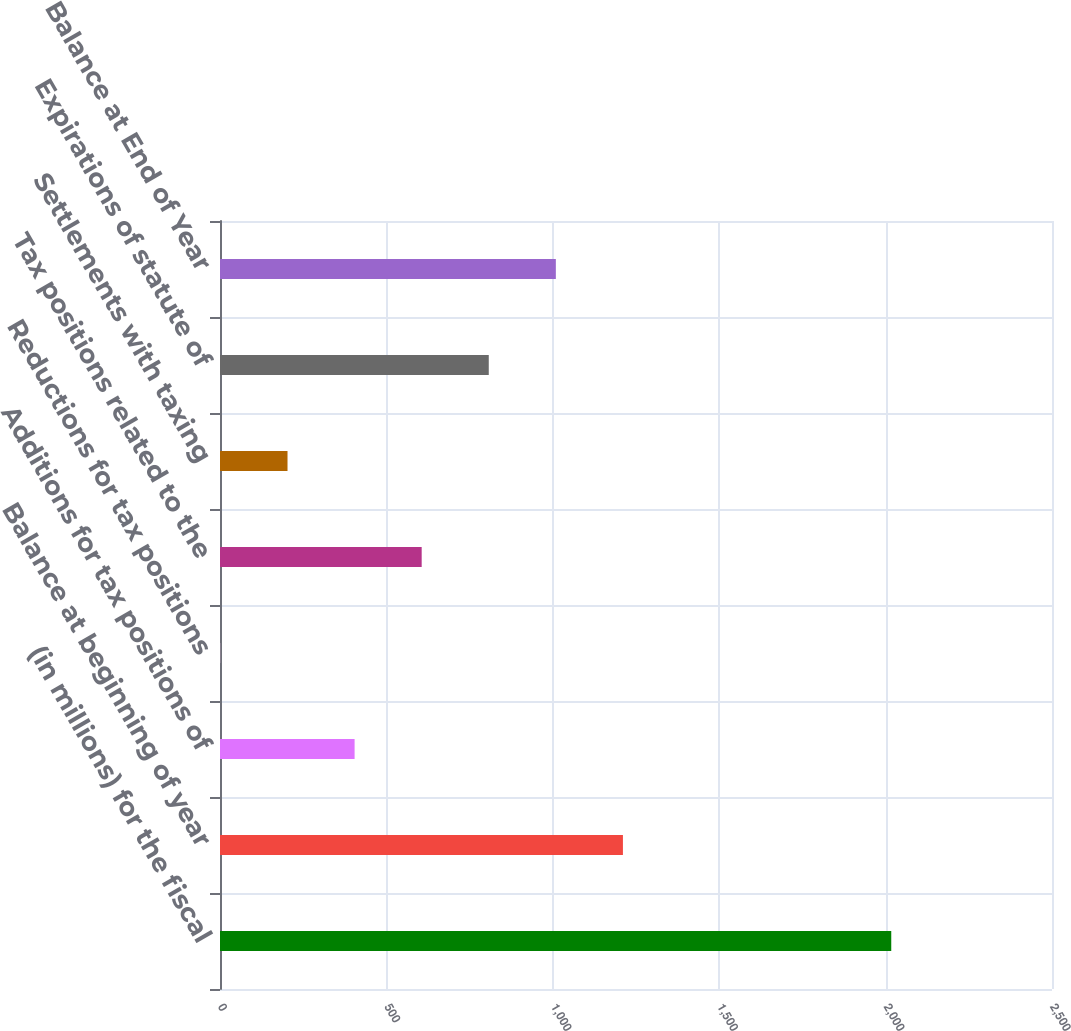<chart> <loc_0><loc_0><loc_500><loc_500><bar_chart><fcel>(in millions) for the fiscal<fcel>Balance at beginning of year<fcel>Additions for tax positions of<fcel>Reductions for tax positions<fcel>Tax positions related to the<fcel>Settlements with taxing<fcel>Expirations of statute of<fcel>Balance at End of Year<nl><fcel>2017<fcel>1210.72<fcel>404.44<fcel>1.3<fcel>606.01<fcel>202.87<fcel>807.58<fcel>1009.15<nl></chart> 